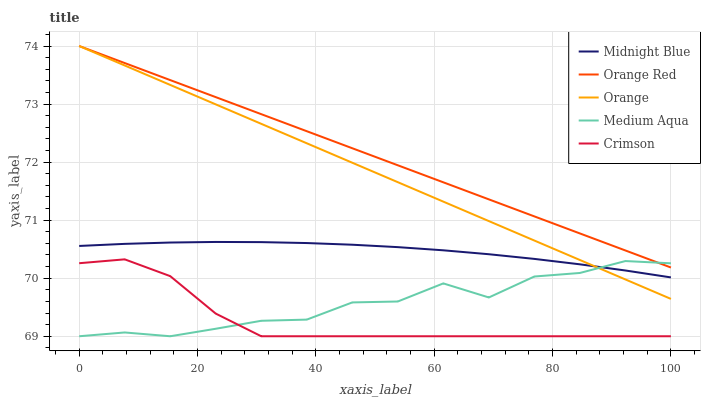Does Crimson have the minimum area under the curve?
Answer yes or no. Yes. Does Orange Red have the maximum area under the curve?
Answer yes or no. Yes. Does Medium Aqua have the minimum area under the curve?
Answer yes or no. No. Does Medium Aqua have the maximum area under the curve?
Answer yes or no. No. Is Orange Red the smoothest?
Answer yes or no. Yes. Is Medium Aqua the roughest?
Answer yes or no. Yes. Is Crimson the smoothest?
Answer yes or no. No. Is Crimson the roughest?
Answer yes or no. No. Does Crimson have the lowest value?
Answer yes or no. Yes. Does Midnight Blue have the lowest value?
Answer yes or no. No. Does Orange Red have the highest value?
Answer yes or no. Yes. Does Crimson have the highest value?
Answer yes or no. No. Is Crimson less than Orange?
Answer yes or no. Yes. Is Midnight Blue greater than Crimson?
Answer yes or no. Yes. Does Medium Aqua intersect Crimson?
Answer yes or no. Yes. Is Medium Aqua less than Crimson?
Answer yes or no. No. Is Medium Aqua greater than Crimson?
Answer yes or no. No. Does Crimson intersect Orange?
Answer yes or no. No. 